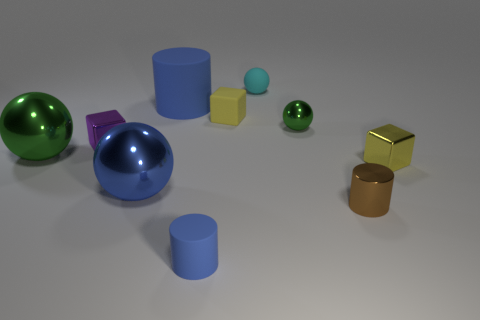Subtract all yellow cubes. How many cubes are left? 1 Subtract 2 cubes. How many cubes are left? 1 Subtract all spheres. How many objects are left? 6 Add 4 big cylinders. How many big cylinders exist? 5 Subtract all blue spheres. How many spheres are left? 3 Subtract 0 gray cubes. How many objects are left? 10 Subtract all cyan cubes. Subtract all red cylinders. How many cubes are left? 3 Subtract all purple cubes. How many gray spheres are left? 0 Subtract all blue cylinders. Subtract all small metallic balls. How many objects are left? 7 Add 4 small blue matte cylinders. How many small blue matte cylinders are left? 5 